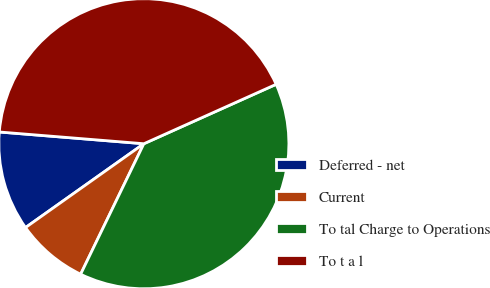Convert chart. <chart><loc_0><loc_0><loc_500><loc_500><pie_chart><fcel>Deferred - net<fcel>Current<fcel>To tal Charge to Operations<fcel>To t a l<nl><fcel>11.1%<fcel>8.01%<fcel>38.9%<fcel>41.99%<nl></chart> 